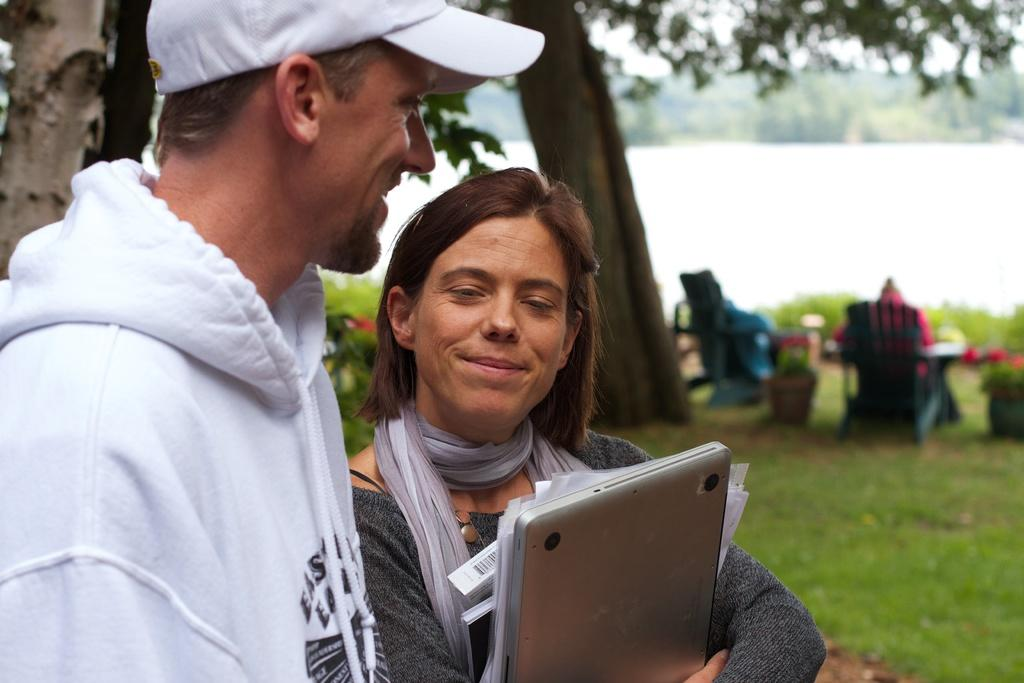How many people are in the image? There are two people in the image. What is one person holding in the image? One person is holding a laptop and papers. What can be seen in the background of the image? There are plants, grass, trees, and two people sitting on chairs in the background. Is there any water visible in the image? Yes, there is water visible in the image. What type of vegetable is being used as a cloth to clean the laptop in the image? There is no vegetable being used as a cloth to clean the laptop in the image. 